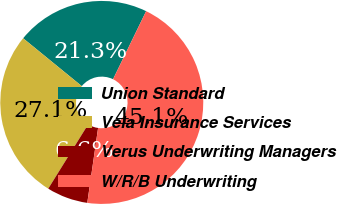Convert chart. <chart><loc_0><loc_0><loc_500><loc_500><pie_chart><fcel>Union Standard<fcel>Vela Insurance Services<fcel>Verus Underwriting Managers<fcel>W/R/B Underwriting<nl><fcel>21.31%<fcel>27.05%<fcel>6.56%<fcel>45.08%<nl></chart> 